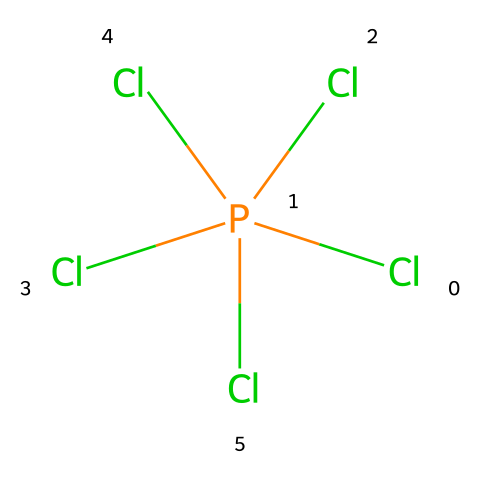how many chlorine atoms are present in phosphorus pentachloride? The chemical structure represented shows one phosphorus atom surrounded by five chlorine atoms connected by single bonds.
Answer: five what is the central atom in the structure of phosphorus pentachloride? The representation clearly indicates that the phosphorus atom is the central atom with surrounding chlorine atoms bonded to it.
Answer: phosphorus how many bonds does phosphorus form in phosphorus pentachloride? The structure indicates that each of the five chlorine atoms is bonded to the central phosphorus atom with single bonds, totaling five bonds.
Answer: five what type of compound is phosphorus pentachloride classified as? The presence of five bonds around phosphorus, which exceeds the typical octet rule, categorizes it as a hypervalent compound.
Answer: hypervalent is phosphorus pentachloride a stable compound? The bonds in phosphorus pentachloride are stable under normal conditions, contributing to its use in various applications, including leather treatments.
Answer: yes how does phosphorus pentachloride differ from typical octet rule compounds? Unlike typical compounds that follow the octet rule, phosphorus pentachloride has more than eight electrons around phosphorus due to its hypervalent nature.
Answer: hypervalent nature what is the main application of phosphorus pentachloride in luxury car treatments? Phosphorus pentachloride is used to treat leather materials to enhance durability and resistance to environmental factors.
Answer: leather treatment 